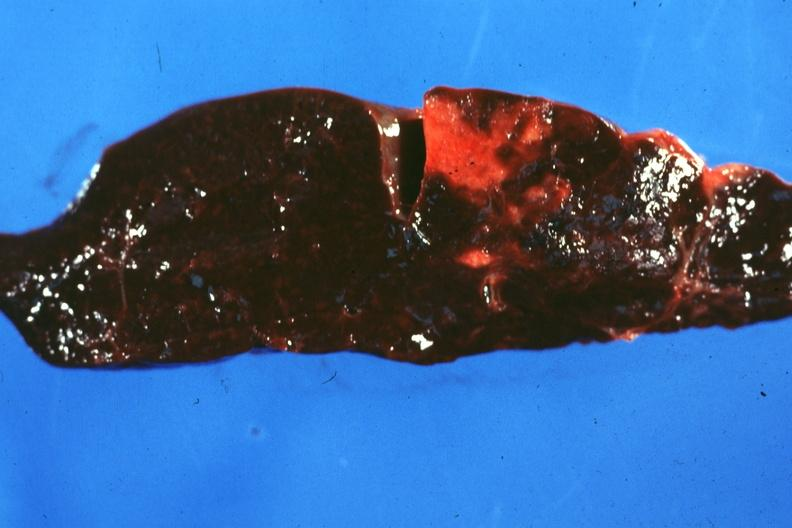what is present?
Answer the question using a single word or phrase. Hematologic 